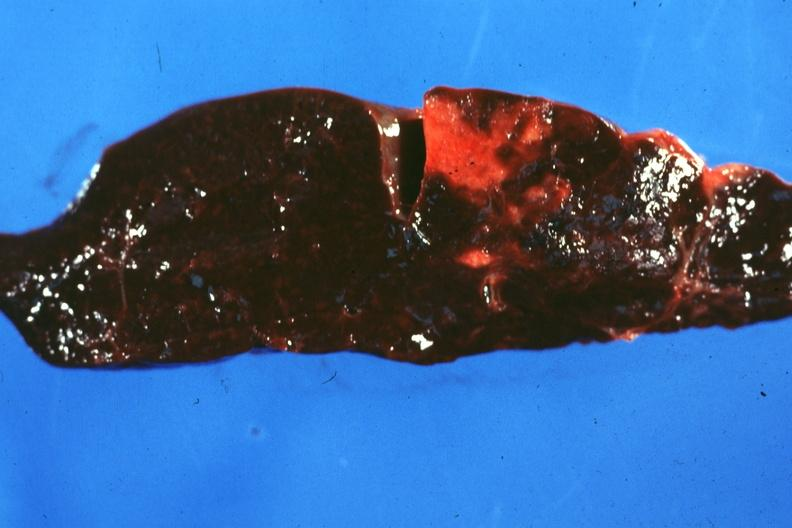what is present?
Answer the question using a single word or phrase. Hematologic 